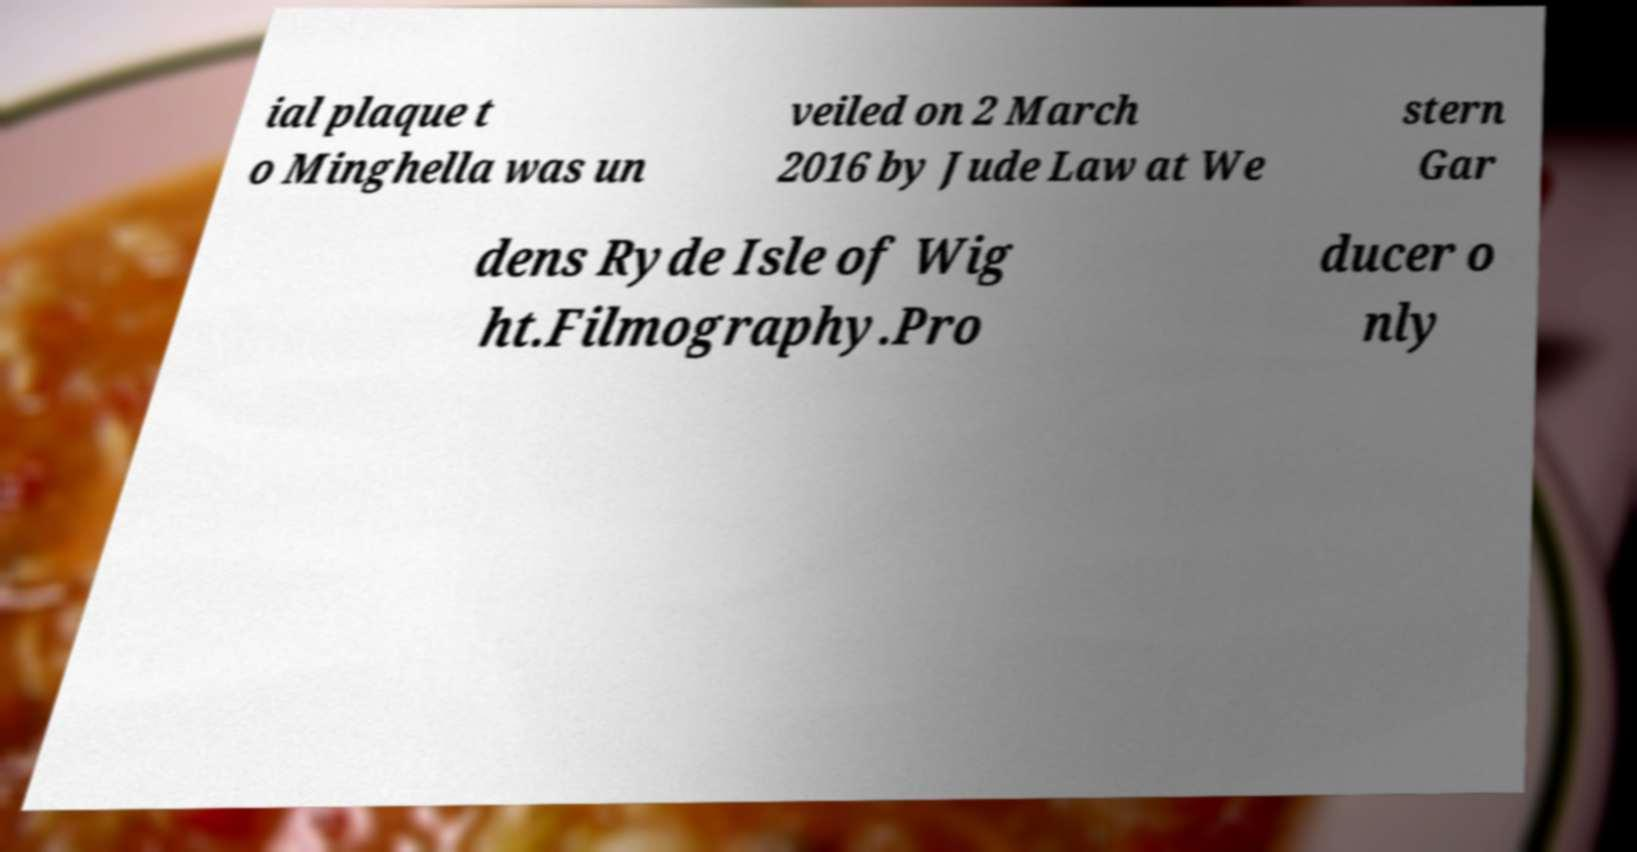I need the written content from this picture converted into text. Can you do that? ial plaque t o Minghella was un veiled on 2 March 2016 by Jude Law at We stern Gar dens Ryde Isle of Wig ht.Filmography.Pro ducer o nly 